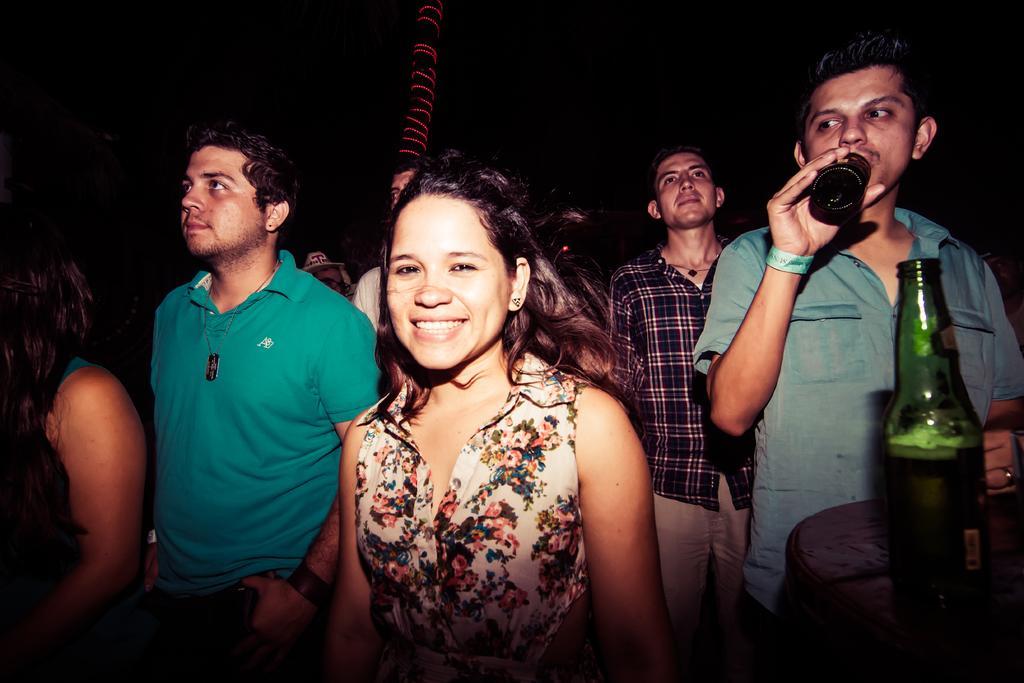In one or two sentences, can you explain what this image depicts? In this image we can see these people are standing and this person is holding a bottle in his hands. On the right side of the image we can see a green color bottle. 